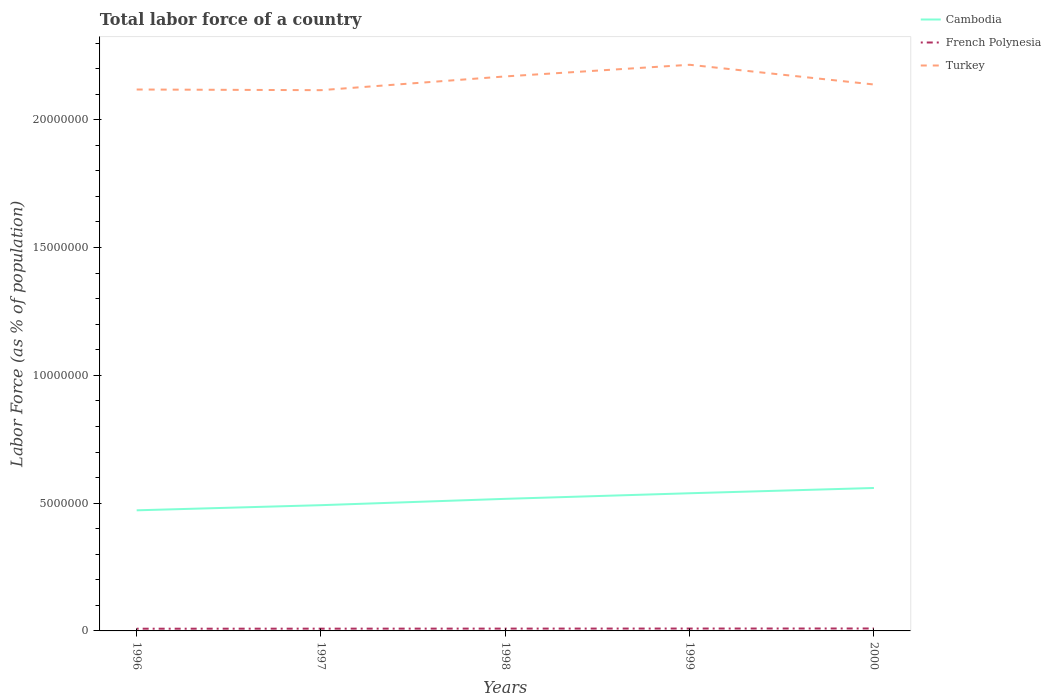How many different coloured lines are there?
Offer a very short reply. 3. Is the number of lines equal to the number of legend labels?
Give a very brief answer. Yes. Across all years, what is the maximum percentage of labor force in Turkey?
Your answer should be very brief. 2.12e+07. In which year was the percentage of labor force in Cambodia maximum?
Your response must be concise. 1996. What is the total percentage of labor force in French Polynesia in the graph?
Provide a short and direct response. -4411. What is the difference between the highest and the second highest percentage of labor force in Cambodia?
Your answer should be very brief. 8.73e+05. Is the percentage of labor force in French Polynesia strictly greater than the percentage of labor force in Turkey over the years?
Your answer should be very brief. Yes. How many lines are there?
Keep it short and to the point. 3. Are the values on the major ticks of Y-axis written in scientific E-notation?
Provide a short and direct response. No. Does the graph contain any zero values?
Make the answer very short. No. Does the graph contain grids?
Give a very brief answer. No. How many legend labels are there?
Your answer should be compact. 3. What is the title of the graph?
Offer a terse response. Total labor force of a country. Does "Russian Federation" appear as one of the legend labels in the graph?
Ensure brevity in your answer.  No. What is the label or title of the X-axis?
Make the answer very short. Years. What is the label or title of the Y-axis?
Ensure brevity in your answer.  Labor Force (as % of population). What is the Labor Force (as % of population) of Cambodia in 1996?
Your answer should be very brief. 4.72e+06. What is the Labor Force (as % of population) in French Polynesia in 1996?
Offer a very short reply. 8.65e+04. What is the Labor Force (as % of population) of Turkey in 1996?
Your answer should be compact. 2.12e+07. What is the Labor Force (as % of population) in Cambodia in 1997?
Provide a short and direct response. 4.92e+06. What is the Labor Force (as % of population) in French Polynesia in 1997?
Ensure brevity in your answer.  8.86e+04. What is the Labor Force (as % of population) in Turkey in 1997?
Offer a very short reply. 2.12e+07. What is the Labor Force (as % of population) in Cambodia in 1998?
Provide a short and direct response. 5.17e+06. What is the Labor Force (as % of population) in French Polynesia in 1998?
Offer a very short reply. 9.08e+04. What is the Labor Force (as % of population) in Turkey in 1998?
Provide a short and direct response. 2.17e+07. What is the Labor Force (as % of population) in Cambodia in 1999?
Keep it short and to the point. 5.39e+06. What is the Labor Force (as % of population) of French Polynesia in 1999?
Your answer should be compact. 9.30e+04. What is the Labor Force (as % of population) in Turkey in 1999?
Your answer should be compact. 2.22e+07. What is the Labor Force (as % of population) in Cambodia in 2000?
Your response must be concise. 5.59e+06. What is the Labor Force (as % of population) in French Polynesia in 2000?
Provide a short and direct response. 9.52e+04. What is the Labor Force (as % of population) of Turkey in 2000?
Ensure brevity in your answer.  2.14e+07. Across all years, what is the maximum Labor Force (as % of population) in Cambodia?
Offer a very short reply. 5.59e+06. Across all years, what is the maximum Labor Force (as % of population) of French Polynesia?
Provide a short and direct response. 9.52e+04. Across all years, what is the maximum Labor Force (as % of population) in Turkey?
Your answer should be compact. 2.22e+07. Across all years, what is the minimum Labor Force (as % of population) of Cambodia?
Provide a short and direct response. 4.72e+06. Across all years, what is the minimum Labor Force (as % of population) in French Polynesia?
Provide a short and direct response. 8.65e+04. Across all years, what is the minimum Labor Force (as % of population) of Turkey?
Offer a terse response. 2.12e+07. What is the total Labor Force (as % of population) of Cambodia in the graph?
Your answer should be very brief. 2.58e+07. What is the total Labor Force (as % of population) of French Polynesia in the graph?
Offer a terse response. 4.54e+05. What is the total Labor Force (as % of population) in Turkey in the graph?
Ensure brevity in your answer.  1.08e+08. What is the difference between the Labor Force (as % of population) of Cambodia in 1996 and that in 1997?
Make the answer very short. -2.01e+05. What is the difference between the Labor Force (as % of population) in French Polynesia in 1996 and that in 1997?
Keep it short and to the point. -2146. What is the difference between the Labor Force (as % of population) in Turkey in 1996 and that in 1997?
Keep it short and to the point. 2.57e+04. What is the difference between the Labor Force (as % of population) of Cambodia in 1996 and that in 1998?
Keep it short and to the point. -4.49e+05. What is the difference between the Labor Force (as % of population) in French Polynesia in 1996 and that in 1998?
Give a very brief answer. -4340. What is the difference between the Labor Force (as % of population) in Turkey in 1996 and that in 1998?
Provide a short and direct response. -5.12e+05. What is the difference between the Labor Force (as % of population) in Cambodia in 1996 and that in 1999?
Offer a terse response. -6.67e+05. What is the difference between the Labor Force (as % of population) in French Polynesia in 1996 and that in 1999?
Your answer should be compact. -6544. What is the difference between the Labor Force (as % of population) of Turkey in 1996 and that in 1999?
Your answer should be very brief. -9.68e+05. What is the difference between the Labor Force (as % of population) of Cambodia in 1996 and that in 2000?
Keep it short and to the point. -8.73e+05. What is the difference between the Labor Force (as % of population) of French Polynesia in 1996 and that in 2000?
Offer a terse response. -8751. What is the difference between the Labor Force (as % of population) in Turkey in 1996 and that in 2000?
Provide a short and direct response. -1.96e+05. What is the difference between the Labor Force (as % of population) of Cambodia in 1997 and that in 1998?
Offer a very short reply. -2.48e+05. What is the difference between the Labor Force (as % of population) of French Polynesia in 1997 and that in 1998?
Keep it short and to the point. -2194. What is the difference between the Labor Force (as % of population) in Turkey in 1997 and that in 1998?
Provide a succinct answer. -5.38e+05. What is the difference between the Labor Force (as % of population) of Cambodia in 1997 and that in 1999?
Your answer should be very brief. -4.66e+05. What is the difference between the Labor Force (as % of population) in French Polynesia in 1997 and that in 1999?
Provide a short and direct response. -4398. What is the difference between the Labor Force (as % of population) in Turkey in 1997 and that in 1999?
Give a very brief answer. -9.94e+05. What is the difference between the Labor Force (as % of population) of Cambodia in 1997 and that in 2000?
Your answer should be compact. -6.72e+05. What is the difference between the Labor Force (as % of population) in French Polynesia in 1997 and that in 2000?
Make the answer very short. -6605. What is the difference between the Labor Force (as % of population) in Turkey in 1997 and that in 2000?
Ensure brevity in your answer.  -2.22e+05. What is the difference between the Labor Force (as % of population) in Cambodia in 1998 and that in 1999?
Your answer should be compact. -2.19e+05. What is the difference between the Labor Force (as % of population) in French Polynesia in 1998 and that in 1999?
Provide a short and direct response. -2204. What is the difference between the Labor Force (as % of population) in Turkey in 1998 and that in 1999?
Make the answer very short. -4.56e+05. What is the difference between the Labor Force (as % of population) in Cambodia in 1998 and that in 2000?
Provide a short and direct response. -4.25e+05. What is the difference between the Labor Force (as % of population) in French Polynesia in 1998 and that in 2000?
Your answer should be very brief. -4411. What is the difference between the Labor Force (as % of population) of Turkey in 1998 and that in 2000?
Provide a succinct answer. 3.16e+05. What is the difference between the Labor Force (as % of population) of Cambodia in 1999 and that in 2000?
Your answer should be compact. -2.06e+05. What is the difference between the Labor Force (as % of population) of French Polynesia in 1999 and that in 2000?
Make the answer very short. -2207. What is the difference between the Labor Force (as % of population) of Turkey in 1999 and that in 2000?
Give a very brief answer. 7.72e+05. What is the difference between the Labor Force (as % of population) of Cambodia in 1996 and the Labor Force (as % of population) of French Polynesia in 1997?
Keep it short and to the point. 4.63e+06. What is the difference between the Labor Force (as % of population) of Cambodia in 1996 and the Labor Force (as % of population) of Turkey in 1997?
Your answer should be very brief. -1.64e+07. What is the difference between the Labor Force (as % of population) of French Polynesia in 1996 and the Labor Force (as % of population) of Turkey in 1997?
Your answer should be compact. -2.11e+07. What is the difference between the Labor Force (as % of population) in Cambodia in 1996 and the Labor Force (as % of population) in French Polynesia in 1998?
Provide a short and direct response. 4.63e+06. What is the difference between the Labor Force (as % of population) in Cambodia in 1996 and the Labor Force (as % of population) in Turkey in 1998?
Your response must be concise. -1.70e+07. What is the difference between the Labor Force (as % of population) in French Polynesia in 1996 and the Labor Force (as % of population) in Turkey in 1998?
Keep it short and to the point. -2.16e+07. What is the difference between the Labor Force (as % of population) of Cambodia in 1996 and the Labor Force (as % of population) of French Polynesia in 1999?
Ensure brevity in your answer.  4.63e+06. What is the difference between the Labor Force (as % of population) in Cambodia in 1996 and the Labor Force (as % of population) in Turkey in 1999?
Give a very brief answer. -1.74e+07. What is the difference between the Labor Force (as % of population) in French Polynesia in 1996 and the Labor Force (as % of population) in Turkey in 1999?
Offer a terse response. -2.21e+07. What is the difference between the Labor Force (as % of population) of Cambodia in 1996 and the Labor Force (as % of population) of French Polynesia in 2000?
Make the answer very short. 4.62e+06. What is the difference between the Labor Force (as % of population) in Cambodia in 1996 and the Labor Force (as % of population) in Turkey in 2000?
Offer a terse response. -1.67e+07. What is the difference between the Labor Force (as % of population) of French Polynesia in 1996 and the Labor Force (as % of population) of Turkey in 2000?
Offer a terse response. -2.13e+07. What is the difference between the Labor Force (as % of population) in Cambodia in 1997 and the Labor Force (as % of population) in French Polynesia in 1998?
Provide a succinct answer. 4.83e+06. What is the difference between the Labor Force (as % of population) in Cambodia in 1997 and the Labor Force (as % of population) in Turkey in 1998?
Your answer should be compact. -1.68e+07. What is the difference between the Labor Force (as % of population) in French Polynesia in 1997 and the Labor Force (as % of population) in Turkey in 1998?
Your response must be concise. -2.16e+07. What is the difference between the Labor Force (as % of population) of Cambodia in 1997 and the Labor Force (as % of population) of French Polynesia in 1999?
Ensure brevity in your answer.  4.83e+06. What is the difference between the Labor Force (as % of population) in Cambodia in 1997 and the Labor Force (as % of population) in Turkey in 1999?
Provide a succinct answer. -1.72e+07. What is the difference between the Labor Force (as % of population) in French Polynesia in 1997 and the Labor Force (as % of population) in Turkey in 1999?
Make the answer very short. -2.21e+07. What is the difference between the Labor Force (as % of population) in Cambodia in 1997 and the Labor Force (as % of population) in French Polynesia in 2000?
Ensure brevity in your answer.  4.82e+06. What is the difference between the Labor Force (as % of population) of Cambodia in 1997 and the Labor Force (as % of population) of Turkey in 2000?
Keep it short and to the point. -1.65e+07. What is the difference between the Labor Force (as % of population) in French Polynesia in 1997 and the Labor Force (as % of population) in Turkey in 2000?
Make the answer very short. -2.13e+07. What is the difference between the Labor Force (as % of population) in Cambodia in 1998 and the Labor Force (as % of population) in French Polynesia in 1999?
Your answer should be very brief. 5.07e+06. What is the difference between the Labor Force (as % of population) of Cambodia in 1998 and the Labor Force (as % of population) of Turkey in 1999?
Provide a short and direct response. -1.70e+07. What is the difference between the Labor Force (as % of population) in French Polynesia in 1998 and the Labor Force (as % of population) in Turkey in 1999?
Your answer should be compact. -2.21e+07. What is the difference between the Labor Force (as % of population) in Cambodia in 1998 and the Labor Force (as % of population) in French Polynesia in 2000?
Make the answer very short. 5.07e+06. What is the difference between the Labor Force (as % of population) of Cambodia in 1998 and the Labor Force (as % of population) of Turkey in 2000?
Your response must be concise. -1.62e+07. What is the difference between the Labor Force (as % of population) in French Polynesia in 1998 and the Labor Force (as % of population) in Turkey in 2000?
Ensure brevity in your answer.  -2.13e+07. What is the difference between the Labor Force (as % of population) of Cambodia in 1999 and the Labor Force (as % of population) of French Polynesia in 2000?
Provide a short and direct response. 5.29e+06. What is the difference between the Labor Force (as % of population) in Cambodia in 1999 and the Labor Force (as % of population) in Turkey in 2000?
Keep it short and to the point. -1.60e+07. What is the difference between the Labor Force (as % of population) in French Polynesia in 1999 and the Labor Force (as % of population) in Turkey in 2000?
Keep it short and to the point. -2.13e+07. What is the average Labor Force (as % of population) of Cambodia per year?
Provide a short and direct response. 5.16e+06. What is the average Labor Force (as % of population) of French Polynesia per year?
Your response must be concise. 9.08e+04. What is the average Labor Force (as % of population) in Turkey per year?
Give a very brief answer. 2.15e+07. In the year 1996, what is the difference between the Labor Force (as % of population) in Cambodia and Labor Force (as % of population) in French Polynesia?
Provide a short and direct response. 4.63e+06. In the year 1996, what is the difference between the Labor Force (as % of population) of Cambodia and Labor Force (as % of population) of Turkey?
Make the answer very short. -1.65e+07. In the year 1996, what is the difference between the Labor Force (as % of population) in French Polynesia and Labor Force (as % of population) in Turkey?
Your answer should be very brief. -2.11e+07. In the year 1997, what is the difference between the Labor Force (as % of population) of Cambodia and Labor Force (as % of population) of French Polynesia?
Your answer should be compact. 4.83e+06. In the year 1997, what is the difference between the Labor Force (as % of population) of Cambodia and Labor Force (as % of population) of Turkey?
Provide a short and direct response. -1.62e+07. In the year 1997, what is the difference between the Labor Force (as % of population) in French Polynesia and Labor Force (as % of population) in Turkey?
Offer a very short reply. -2.11e+07. In the year 1998, what is the difference between the Labor Force (as % of population) of Cambodia and Labor Force (as % of population) of French Polynesia?
Your answer should be compact. 5.08e+06. In the year 1998, what is the difference between the Labor Force (as % of population) of Cambodia and Labor Force (as % of population) of Turkey?
Your response must be concise. -1.65e+07. In the year 1998, what is the difference between the Labor Force (as % of population) of French Polynesia and Labor Force (as % of population) of Turkey?
Make the answer very short. -2.16e+07. In the year 1999, what is the difference between the Labor Force (as % of population) of Cambodia and Labor Force (as % of population) of French Polynesia?
Your answer should be compact. 5.29e+06. In the year 1999, what is the difference between the Labor Force (as % of population) in Cambodia and Labor Force (as % of population) in Turkey?
Your response must be concise. -1.68e+07. In the year 1999, what is the difference between the Labor Force (as % of population) in French Polynesia and Labor Force (as % of population) in Turkey?
Your answer should be very brief. -2.21e+07. In the year 2000, what is the difference between the Labor Force (as % of population) in Cambodia and Labor Force (as % of population) in French Polynesia?
Keep it short and to the point. 5.50e+06. In the year 2000, what is the difference between the Labor Force (as % of population) in Cambodia and Labor Force (as % of population) in Turkey?
Offer a very short reply. -1.58e+07. In the year 2000, what is the difference between the Labor Force (as % of population) in French Polynesia and Labor Force (as % of population) in Turkey?
Make the answer very short. -2.13e+07. What is the ratio of the Labor Force (as % of population) of Cambodia in 1996 to that in 1997?
Your answer should be compact. 0.96. What is the ratio of the Labor Force (as % of population) in French Polynesia in 1996 to that in 1997?
Provide a short and direct response. 0.98. What is the ratio of the Labor Force (as % of population) in Turkey in 1996 to that in 1997?
Offer a terse response. 1. What is the ratio of the Labor Force (as % of population) in Cambodia in 1996 to that in 1998?
Make the answer very short. 0.91. What is the ratio of the Labor Force (as % of population) in French Polynesia in 1996 to that in 1998?
Your answer should be very brief. 0.95. What is the ratio of the Labor Force (as % of population) in Turkey in 1996 to that in 1998?
Your answer should be very brief. 0.98. What is the ratio of the Labor Force (as % of population) of Cambodia in 1996 to that in 1999?
Provide a short and direct response. 0.88. What is the ratio of the Labor Force (as % of population) in French Polynesia in 1996 to that in 1999?
Ensure brevity in your answer.  0.93. What is the ratio of the Labor Force (as % of population) of Turkey in 1996 to that in 1999?
Provide a short and direct response. 0.96. What is the ratio of the Labor Force (as % of population) in Cambodia in 1996 to that in 2000?
Keep it short and to the point. 0.84. What is the ratio of the Labor Force (as % of population) in French Polynesia in 1996 to that in 2000?
Your answer should be compact. 0.91. What is the ratio of the Labor Force (as % of population) of Turkey in 1996 to that in 2000?
Provide a short and direct response. 0.99. What is the ratio of the Labor Force (as % of population) in Cambodia in 1997 to that in 1998?
Offer a very short reply. 0.95. What is the ratio of the Labor Force (as % of population) in French Polynesia in 1997 to that in 1998?
Offer a terse response. 0.98. What is the ratio of the Labor Force (as % of population) in Turkey in 1997 to that in 1998?
Your answer should be very brief. 0.98. What is the ratio of the Labor Force (as % of population) in Cambodia in 1997 to that in 1999?
Keep it short and to the point. 0.91. What is the ratio of the Labor Force (as % of population) in French Polynesia in 1997 to that in 1999?
Offer a very short reply. 0.95. What is the ratio of the Labor Force (as % of population) in Turkey in 1997 to that in 1999?
Your answer should be very brief. 0.96. What is the ratio of the Labor Force (as % of population) of Cambodia in 1997 to that in 2000?
Give a very brief answer. 0.88. What is the ratio of the Labor Force (as % of population) in French Polynesia in 1997 to that in 2000?
Make the answer very short. 0.93. What is the ratio of the Labor Force (as % of population) in Cambodia in 1998 to that in 1999?
Your response must be concise. 0.96. What is the ratio of the Labor Force (as % of population) of French Polynesia in 1998 to that in 1999?
Your answer should be very brief. 0.98. What is the ratio of the Labor Force (as % of population) of Turkey in 1998 to that in 1999?
Your response must be concise. 0.98. What is the ratio of the Labor Force (as % of population) of Cambodia in 1998 to that in 2000?
Your response must be concise. 0.92. What is the ratio of the Labor Force (as % of population) in French Polynesia in 1998 to that in 2000?
Keep it short and to the point. 0.95. What is the ratio of the Labor Force (as % of population) of Turkey in 1998 to that in 2000?
Your answer should be very brief. 1.01. What is the ratio of the Labor Force (as % of population) of Cambodia in 1999 to that in 2000?
Your answer should be very brief. 0.96. What is the ratio of the Labor Force (as % of population) in French Polynesia in 1999 to that in 2000?
Provide a succinct answer. 0.98. What is the ratio of the Labor Force (as % of population) in Turkey in 1999 to that in 2000?
Provide a short and direct response. 1.04. What is the difference between the highest and the second highest Labor Force (as % of population) of Cambodia?
Keep it short and to the point. 2.06e+05. What is the difference between the highest and the second highest Labor Force (as % of population) in French Polynesia?
Give a very brief answer. 2207. What is the difference between the highest and the second highest Labor Force (as % of population) of Turkey?
Your answer should be compact. 4.56e+05. What is the difference between the highest and the lowest Labor Force (as % of population) in Cambodia?
Provide a succinct answer. 8.73e+05. What is the difference between the highest and the lowest Labor Force (as % of population) of French Polynesia?
Make the answer very short. 8751. What is the difference between the highest and the lowest Labor Force (as % of population) in Turkey?
Offer a very short reply. 9.94e+05. 